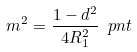Convert formula to latex. <formula><loc_0><loc_0><loc_500><loc_500>m ^ { 2 } = \frac { 1 - d ^ { 2 } } { 4 R _ { 1 } ^ { 2 } } \ p n t</formula> 